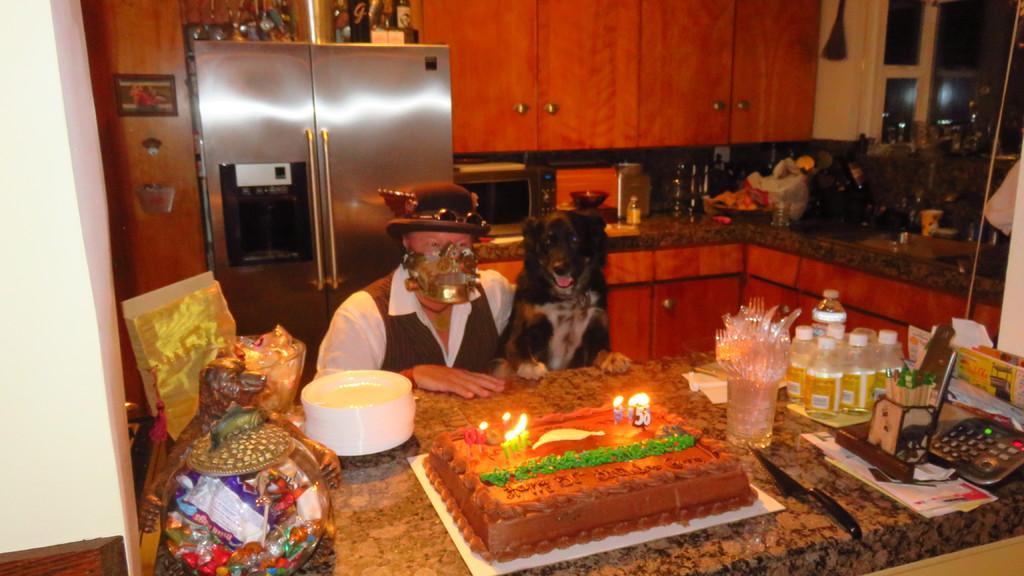In one or two sentences, can you explain what this image depicts? In this image there are bottles, chocolates in a glass bowl, cake with candles on it , bottles ,forks, spoons, and some other items on the table, a person and a dog, and in the background there is a refrigerator, microwave oven , cupboards. 